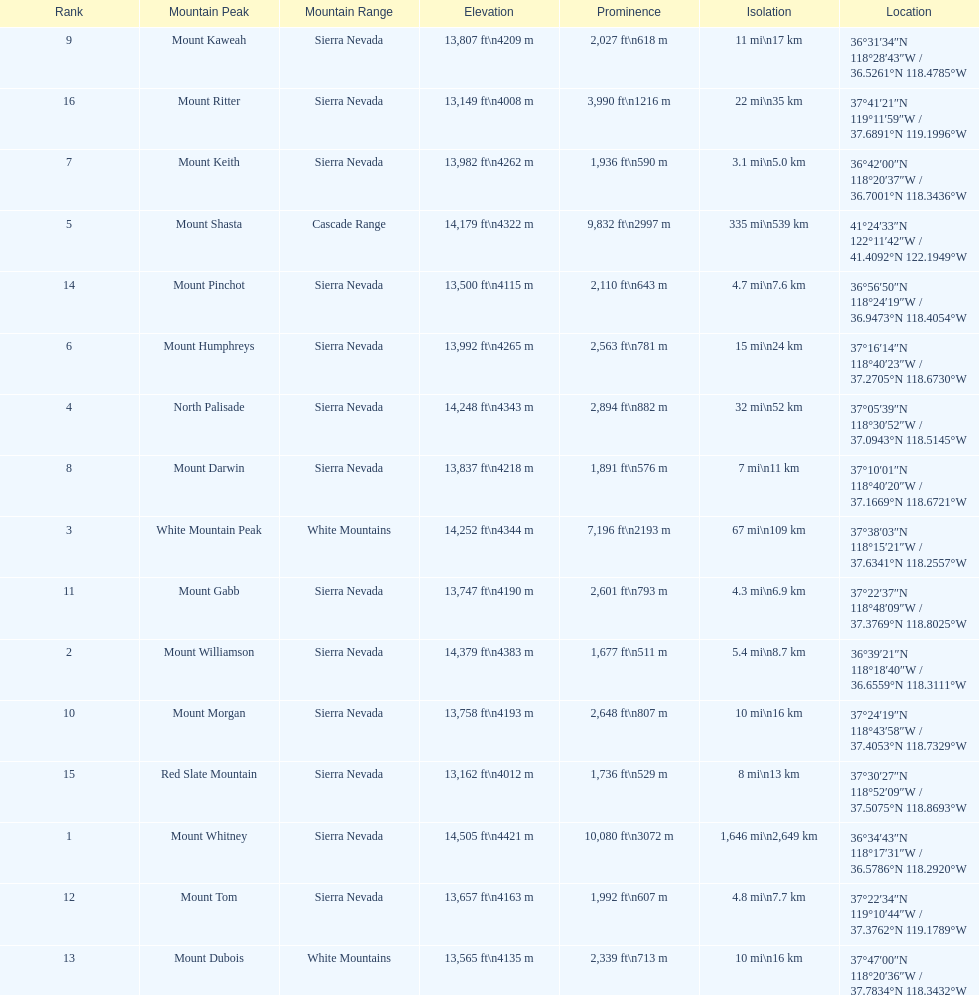In feet, what is the difference between the tallest peak and the 9th tallest peak in california? 698 ft. 